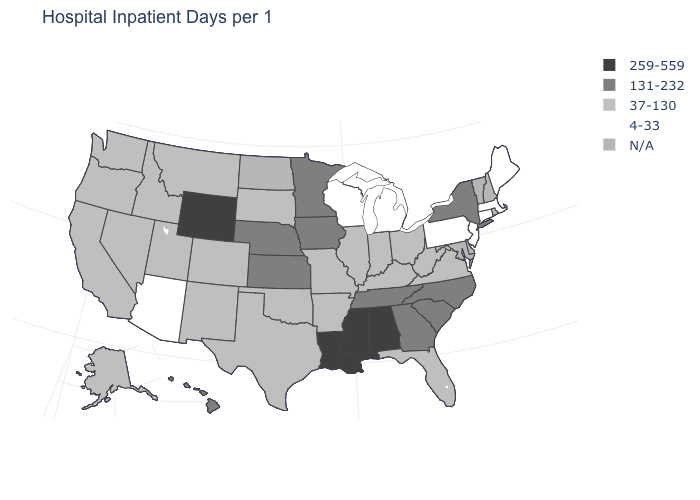Name the states that have a value in the range N/A?
Answer briefly. Delaware, Maryland, New Hampshire, North Dakota, Rhode Island, Vermont. How many symbols are there in the legend?
Keep it brief. 5. How many symbols are there in the legend?
Quick response, please. 5. What is the value of Missouri?
Short answer required. 37-130. What is the value of New York?
Keep it brief. 131-232. What is the value of Ohio?
Be succinct. 37-130. What is the value of Washington?
Quick response, please. 37-130. Name the states that have a value in the range 4-33?
Keep it brief. Arizona, Connecticut, Maine, Massachusetts, Michigan, New Jersey, Pennsylvania, Wisconsin. What is the value of Michigan?
Be succinct. 4-33. What is the value of Nevada?
Short answer required. 37-130. Name the states that have a value in the range 37-130?
Short answer required. Alaska, Arkansas, California, Colorado, Florida, Idaho, Illinois, Indiana, Kentucky, Missouri, Montana, Nevada, New Mexico, Ohio, Oklahoma, Oregon, South Dakota, Texas, Utah, Virginia, Washington, West Virginia. Among the states that border North Dakota , does Montana have the highest value?
Give a very brief answer. No. Does Wyoming have the highest value in the USA?
Write a very short answer. Yes. Does the first symbol in the legend represent the smallest category?
Keep it brief. No. What is the highest value in states that border Oklahoma?
Answer briefly. 131-232. 